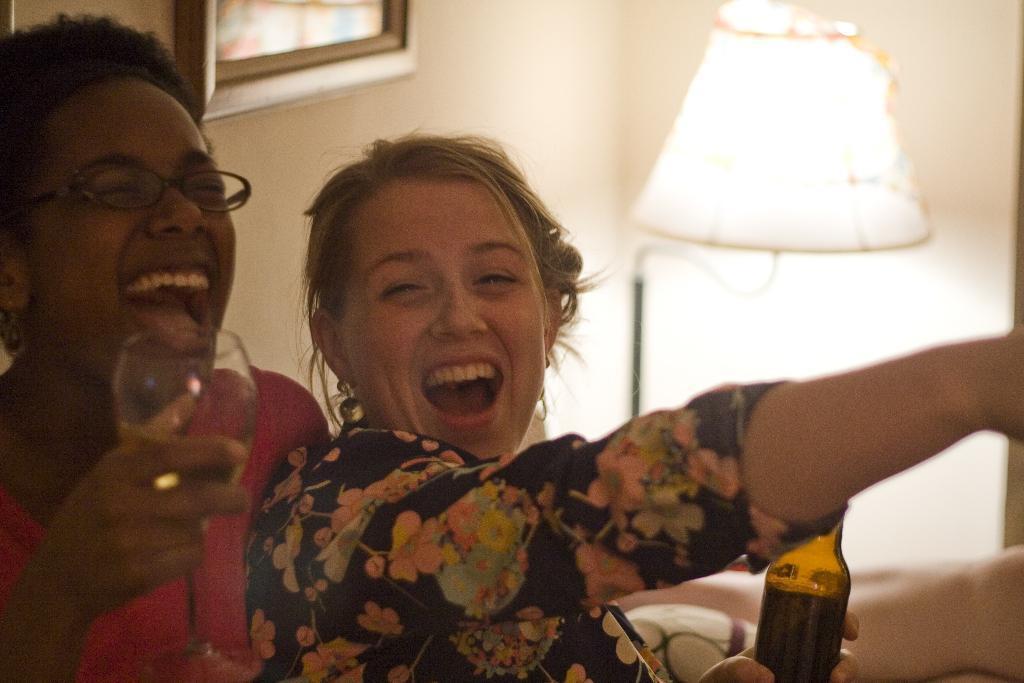Please provide a concise description of this image. In this image we see two ladies are holding a glass and bottle in their hands. In the background we can see a photo frame and lamp. 